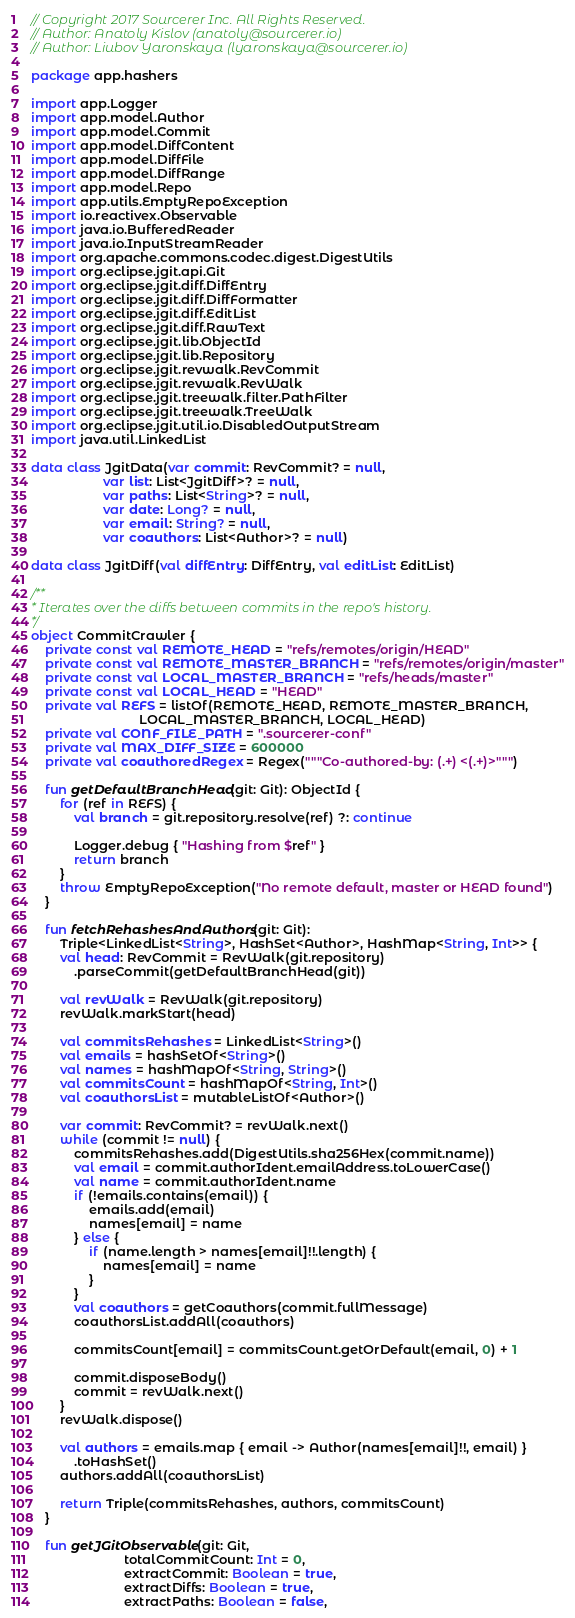Convert code to text. <code><loc_0><loc_0><loc_500><loc_500><_Kotlin_>// Copyright 2017 Sourcerer Inc. All Rights Reserved.
// Author: Anatoly Kislov (anatoly@sourcerer.io)
// Author: Liubov Yaronskaya (lyaronskaya@sourcerer.io)

package app.hashers

import app.Logger
import app.model.Author
import app.model.Commit
import app.model.DiffContent
import app.model.DiffFile
import app.model.DiffRange
import app.model.Repo
import app.utils.EmptyRepoException
import io.reactivex.Observable
import java.io.BufferedReader
import java.io.InputStreamReader
import org.apache.commons.codec.digest.DigestUtils
import org.eclipse.jgit.api.Git
import org.eclipse.jgit.diff.DiffEntry
import org.eclipse.jgit.diff.DiffFormatter
import org.eclipse.jgit.diff.EditList
import org.eclipse.jgit.diff.RawText
import org.eclipse.jgit.lib.ObjectId
import org.eclipse.jgit.lib.Repository
import org.eclipse.jgit.revwalk.RevCommit
import org.eclipse.jgit.revwalk.RevWalk
import org.eclipse.jgit.treewalk.filter.PathFilter
import org.eclipse.jgit.treewalk.TreeWalk
import org.eclipse.jgit.util.io.DisabledOutputStream
import java.util.LinkedList

data class JgitData(var commit: RevCommit? = null,
                    var list: List<JgitDiff>? = null,
                    var paths: List<String>? = null,
                    var date: Long? = null,
                    var email: String? = null,
                    var coauthors: List<Author>? = null)

data class JgitDiff(val diffEntry: DiffEntry, val editList: EditList)

/**
* Iterates over the diffs between commits in the repo's history.
*/
object CommitCrawler {
    private const val REMOTE_HEAD = "refs/remotes/origin/HEAD"
    private const val REMOTE_MASTER_BRANCH = "refs/remotes/origin/master"
    private const val LOCAL_MASTER_BRANCH = "refs/heads/master"
    private const val LOCAL_HEAD = "HEAD"
    private val REFS = listOf(REMOTE_HEAD, REMOTE_MASTER_BRANCH,
                              LOCAL_MASTER_BRANCH, LOCAL_HEAD)
    private val CONF_FILE_PATH = ".sourcerer-conf"
    private val MAX_DIFF_SIZE = 600000
    private val coauthoredRegex = Regex("""Co-authored-by: (.+) <(.+)>""")

    fun getDefaultBranchHead(git: Git): ObjectId {
        for (ref in REFS) {
            val branch = git.repository.resolve(ref) ?: continue

            Logger.debug { "Hashing from $ref" }
            return branch
        }
        throw EmptyRepoException("No remote default, master or HEAD found")
    }

    fun fetchRehashesAndAuthors(git: Git):
        Triple<LinkedList<String>, HashSet<Author>, HashMap<String, Int>> {
        val head: RevCommit = RevWalk(git.repository)
            .parseCommit(getDefaultBranchHead(git))

        val revWalk = RevWalk(git.repository)
        revWalk.markStart(head)

        val commitsRehashes = LinkedList<String>()
        val emails = hashSetOf<String>()
        val names = hashMapOf<String, String>()
        val commitsCount = hashMapOf<String, Int>()
        val coauthorsList = mutableListOf<Author>()

        var commit: RevCommit? = revWalk.next()
        while (commit != null) {
            commitsRehashes.add(DigestUtils.sha256Hex(commit.name))
            val email = commit.authorIdent.emailAddress.toLowerCase()
            val name = commit.authorIdent.name
            if (!emails.contains(email)) {
                emails.add(email)
                names[email] = name
            } else {
                if (name.length > names[email]!!.length) {
                    names[email] = name
                }
            }
            val coauthors = getCoauthors(commit.fullMessage)
            coauthorsList.addAll(coauthors)

            commitsCount[email] = commitsCount.getOrDefault(email, 0) + 1

            commit.disposeBody()
            commit = revWalk.next()
        }
        revWalk.dispose()

        val authors = emails.map { email -> Author(names[email]!!, email) }
            .toHashSet()
        authors.addAll(coauthorsList)

        return Triple(commitsRehashes, authors, commitsCount)
    }

    fun getJGitObservable(git: Git,
                          totalCommitCount: Int = 0,
                          extractCommit: Boolean = true,
                          extractDiffs: Boolean = true,
                          extractPaths: Boolean = false,</code> 